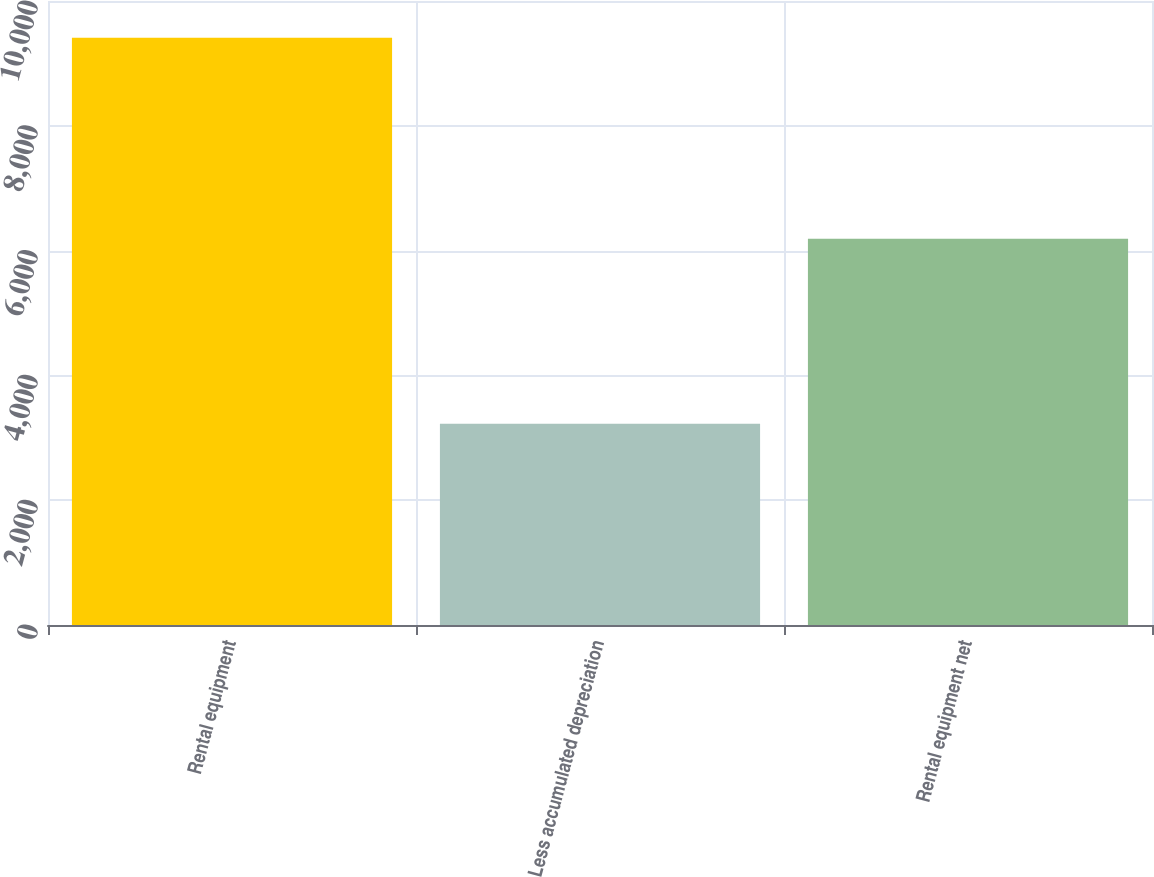<chart> <loc_0><loc_0><loc_500><loc_500><bar_chart><fcel>Rental equipment<fcel>Less accumulated depreciation<fcel>Rental equipment net<nl><fcel>9413<fcel>3224<fcel>6189<nl></chart> 